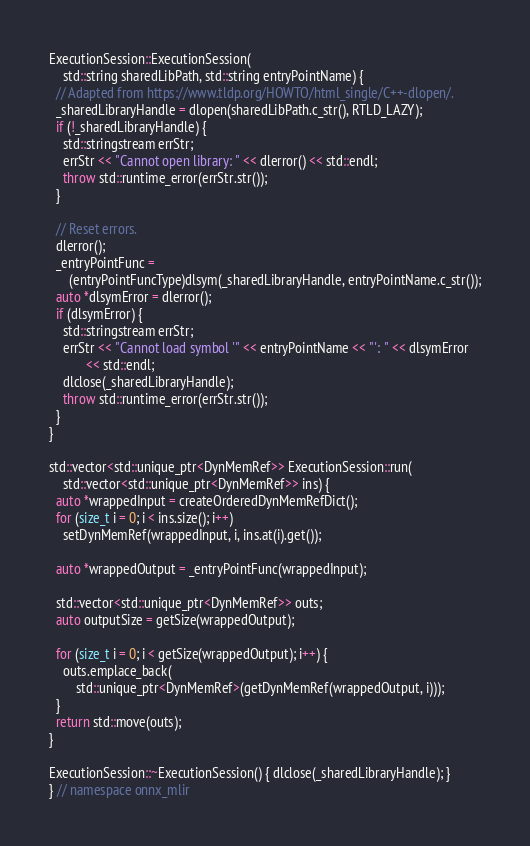<code> <loc_0><loc_0><loc_500><loc_500><_C++_>ExecutionSession::ExecutionSession(
    std::string sharedLibPath, std::string entryPointName) {
  // Adapted from https://www.tldp.org/HOWTO/html_single/C++-dlopen/.
  _sharedLibraryHandle = dlopen(sharedLibPath.c_str(), RTLD_LAZY);
  if (!_sharedLibraryHandle) {
    std::stringstream errStr;
    errStr << "Cannot open library: " << dlerror() << std::endl;
    throw std::runtime_error(errStr.str());
  }

  // Reset errors.
  dlerror();
  _entryPointFunc =
      (entryPointFuncType)dlsym(_sharedLibraryHandle, entryPointName.c_str());
  auto *dlsymError = dlerror();
  if (dlsymError) {
    std::stringstream errStr;
    errStr << "Cannot load symbol '" << entryPointName << "': " << dlsymError
           << std::endl;
    dlclose(_sharedLibraryHandle);
    throw std::runtime_error(errStr.str());
  }
}

std::vector<std::unique_ptr<DynMemRef>> ExecutionSession::run(
    std::vector<std::unique_ptr<DynMemRef>> ins) {
  auto *wrappedInput = createOrderedDynMemRefDict();
  for (size_t i = 0; i < ins.size(); i++)
    setDynMemRef(wrappedInput, i, ins.at(i).get());

  auto *wrappedOutput = _entryPointFunc(wrappedInput);

  std::vector<std::unique_ptr<DynMemRef>> outs;
  auto outputSize = getSize(wrappedOutput);

  for (size_t i = 0; i < getSize(wrappedOutput); i++) {
    outs.emplace_back(
        std::unique_ptr<DynMemRef>(getDynMemRef(wrappedOutput, i)));
  }
  return std::move(outs);
}

ExecutionSession::~ExecutionSession() { dlclose(_sharedLibraryHandle); }
} // namespace onnx_mlir</code> 